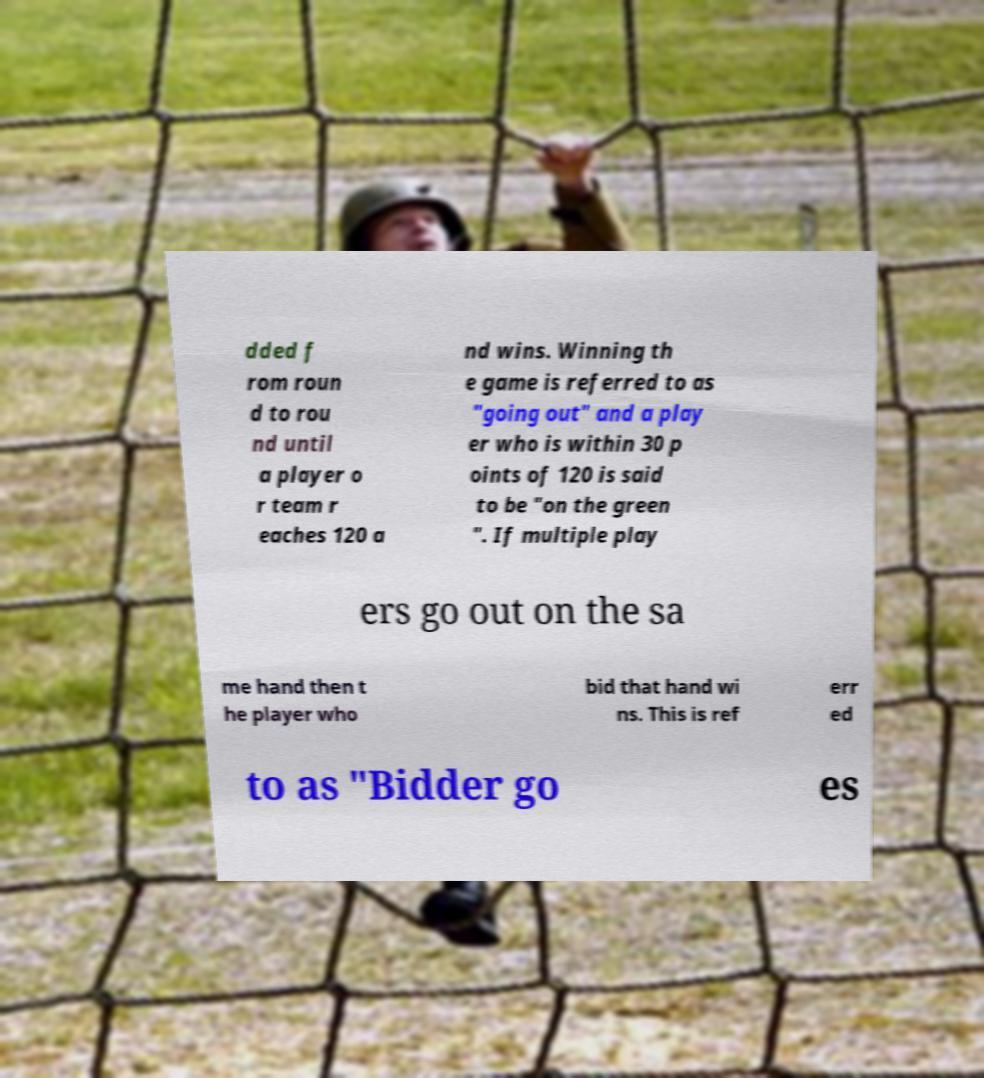For documentation purposes, I need the text within this image transcribed. Could you provide that? dded f rom roun d to rou nd until a player o r team r eaches 120 a nd wins. Winning th e game is referred to as "going out" and a play er who is within 30 p oints of 120 is said to be "on the green ". If multiple play ers go out on the sa me hand then t he player who bid that hand wi ns. This is ref err ed to as "Bidder go es 